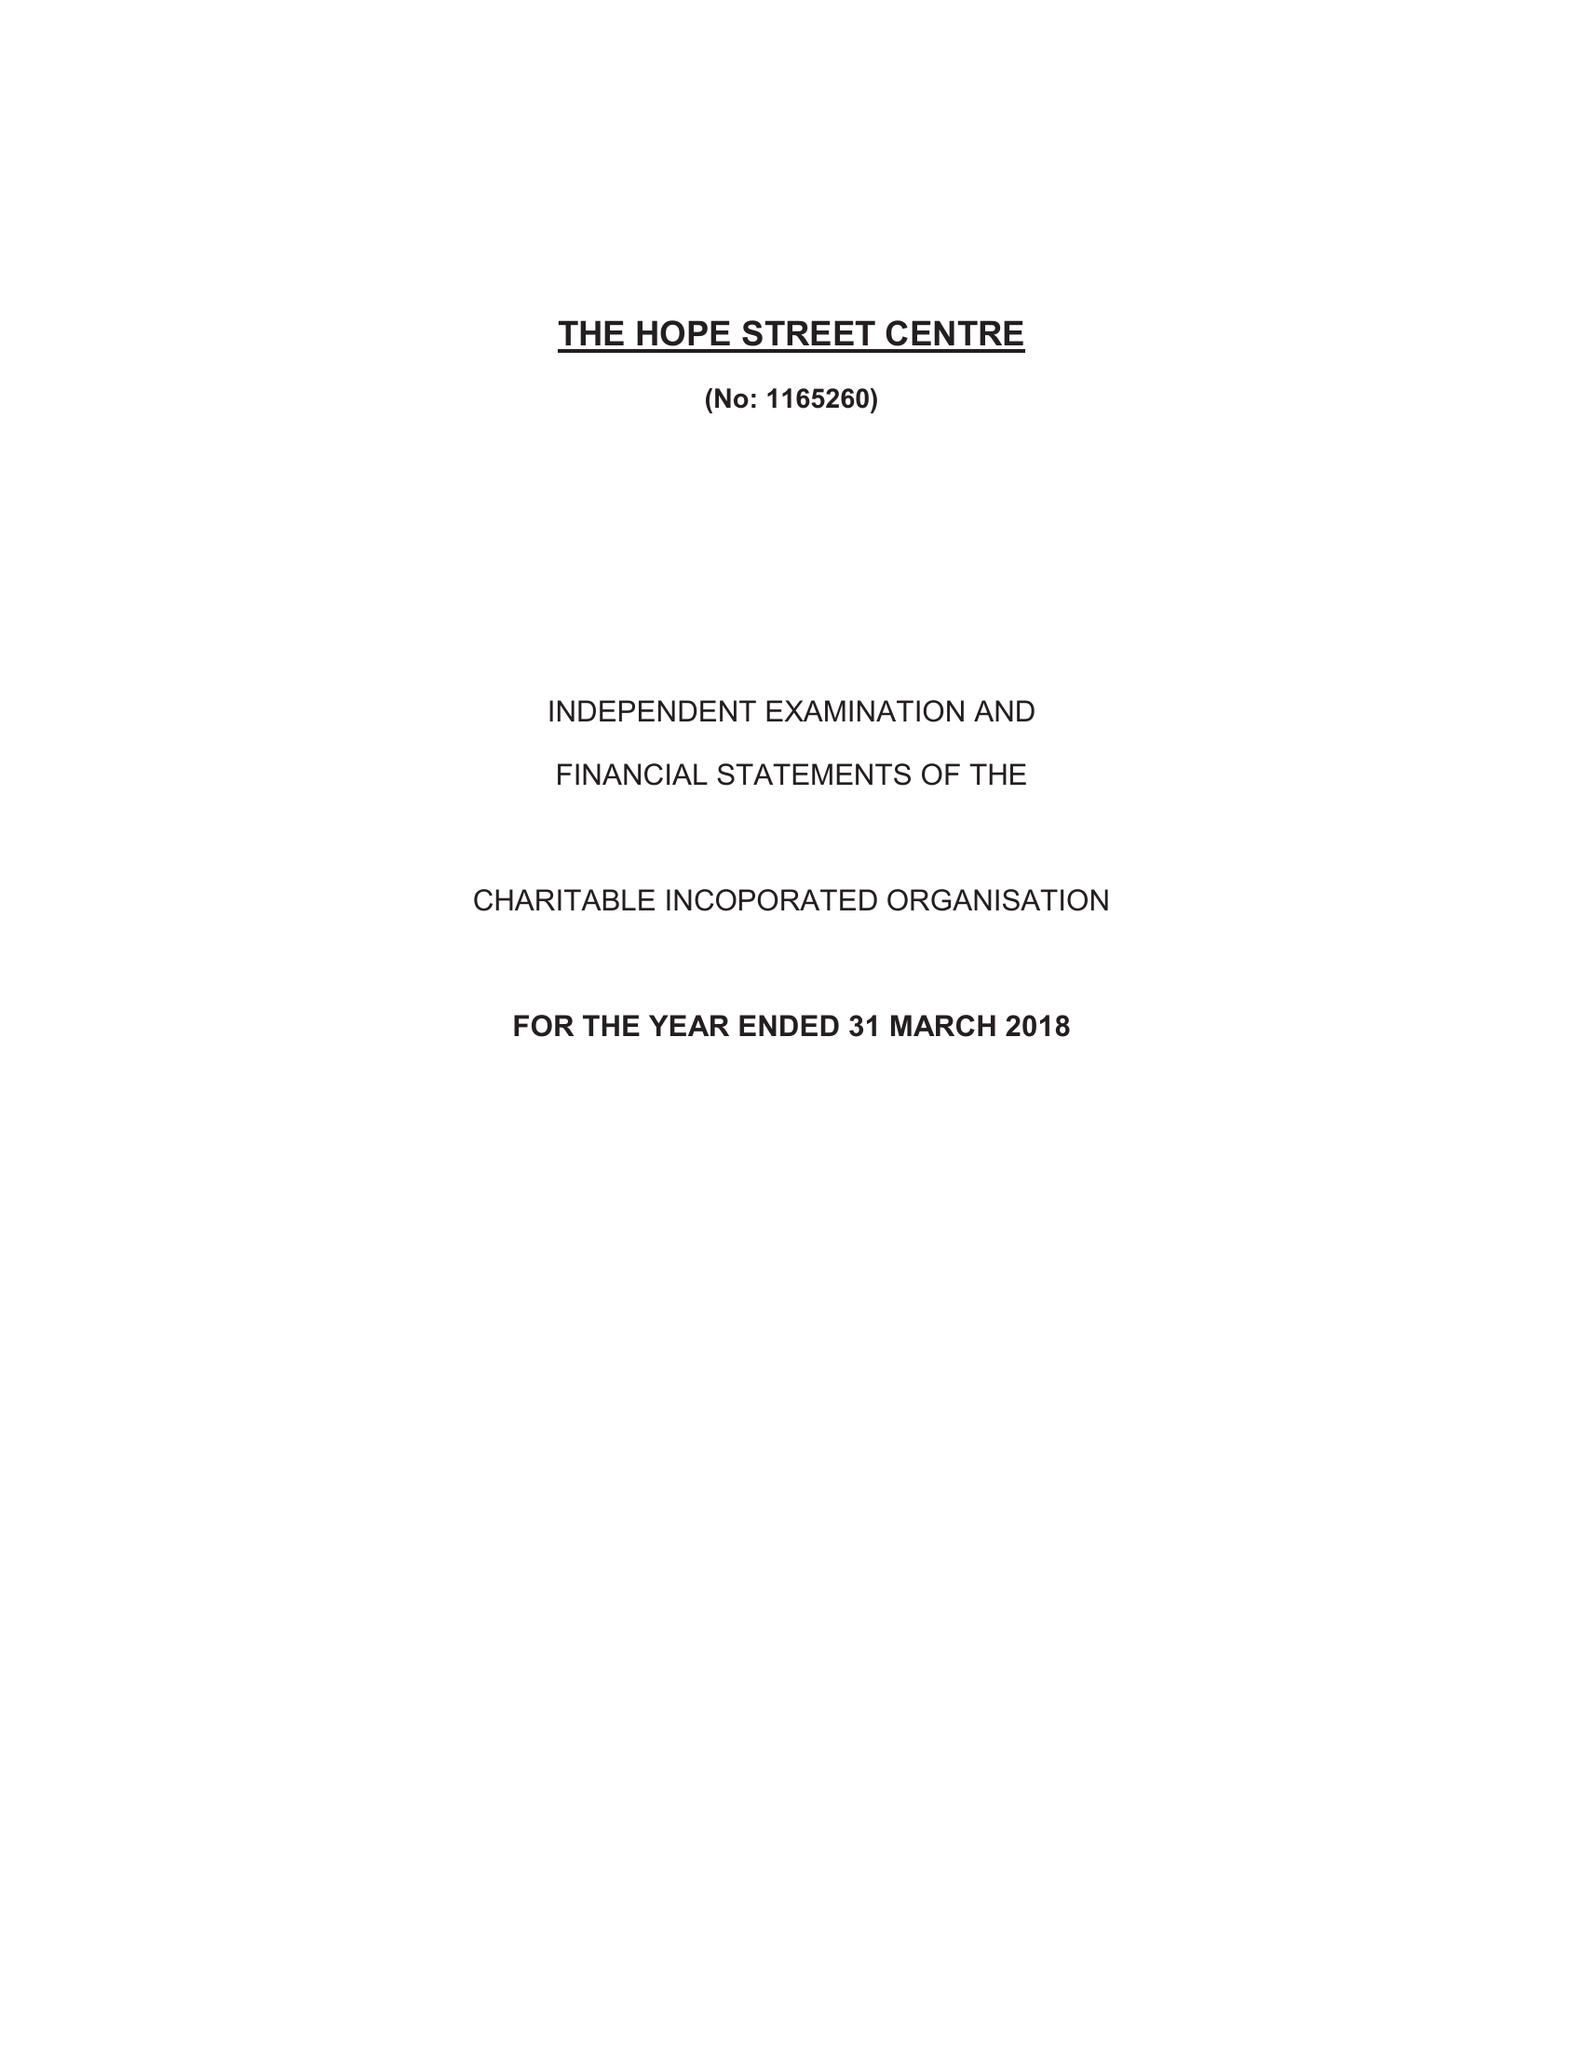What is the value for the income_annually_in_british_pounds?
Answer the question using a single word or phrase. 90045.00 